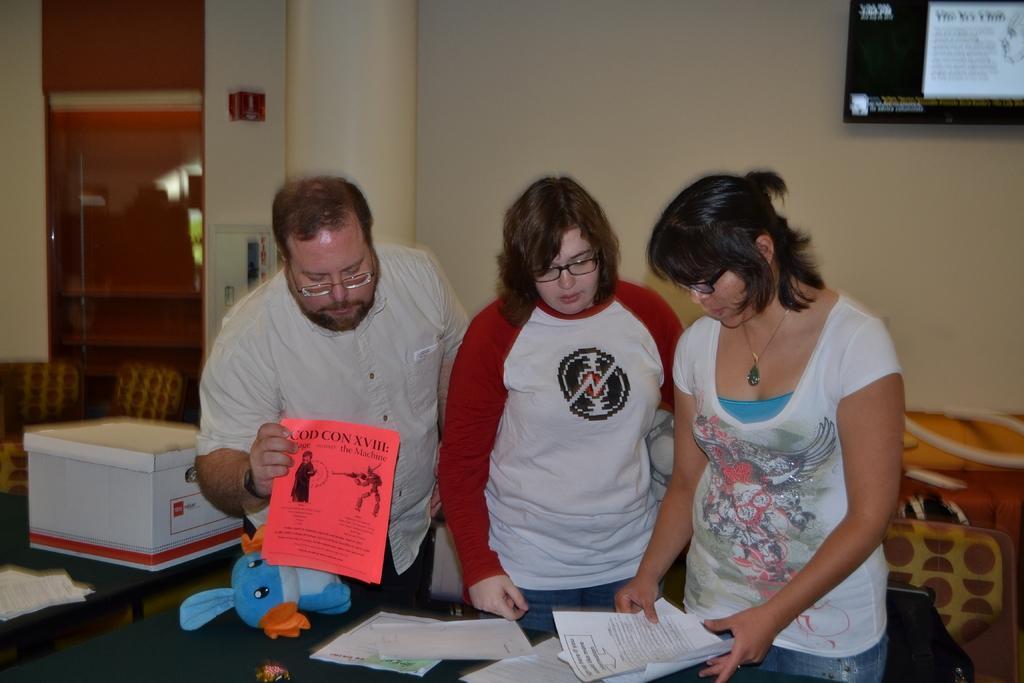How would you summarize this image in a sentence or two? Here we can see a three people who are looking at these papers which are on this table. In the background we can see a television which is fixed to a wall and chairs on the left side and a glass door as well. 